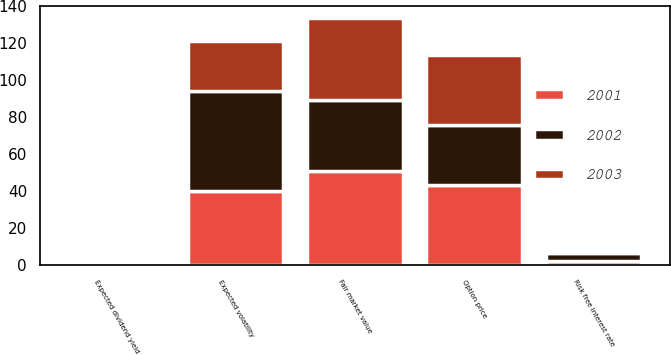<chart> <loc_0><loc_0><loc_500><loc_500><stacked_bar_chart><ecel><fcel>Fair market value<fcel>Option price<fcel>Expected dividend yield<fcel>Expected volatility<fcel>Risk free interest rate<nl><fcel>2003<fcel>44.17<fcel>37.54<fcel>0<fcel>27<fcel>1.26<nl><fcel>2001<fcel>51.14<fcel>43.47<fcel>0<fcel>40<fcel>2.17<nl><fcel>2002<fcel>38.18<fcel>32.45<fcel>0<fcel>54<fcel>4.38<nl></chart> 